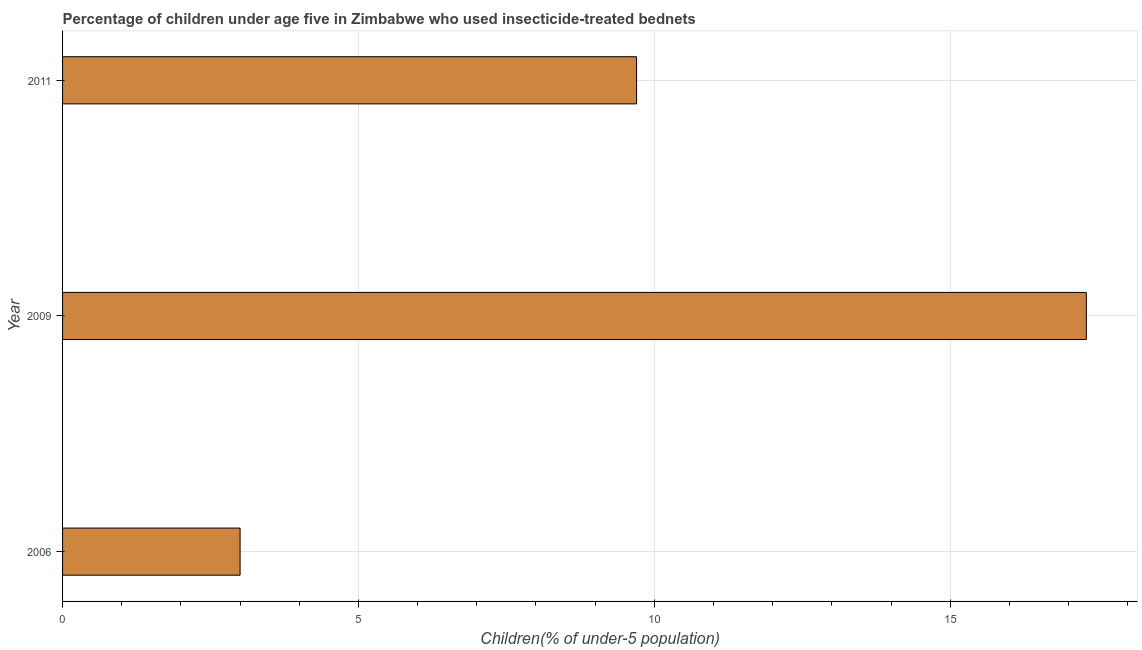Does the graph contain grids?
Ensure brevity in your answer.  Yes. What is the title of the graph?
Keep it short and to the point. Percentage of children under age five in Zimbabwe who used insecticide-treated bednets. What is the label or title of the X-axis?
Provide a short and direct response. Children(% of under-5 population). What is the label or title of the Y-axis?
Keep it short and to the point. Year. Across all years, what is the maximum percentage of children who use of insecticide-treated bed nets?
Provide a short and direct response. 17.3. What is the difference between the percentage of children who use of insecticide-treated bed nets in 2006 and 2011?
Provide a succinct answer. -6.7. What is the median percentage of children who use of insecticide-treated bed nets?
Offer a very short reply. 9.7. Do a majority of the years between 2009 and 2011 (inclusive) have percentage of children who use of insecticide-treated bed nets greater than 16 %?
Ensure brevity in your answer.  No. What is the ratio of the percentage of children who use of insecticide-treated bed nets in 2006 to that in 2009?
Provide a short and direct response. 0.17. Is the difference between the percentage of children who use of insecticide-treated bed nets in 2006 and 2009 greater than the difference between any two years?
Provide a succinct answer. Yes. What is the difference between the highest and the lowest percentage of children who use of insecticide-treated bed nets?
Keep it short and to the point. 14.3. In how many years, is the percentage of children who use of insecticide-treated bed nets greater than the average percentage of children who use of insecticide-treated bed nets taken over all years?
Your answer should be very brief. 1. How many years are there in the graph?
Provide a succinct answer. 3. Are the values on the major ticks of X-axis written in scientific E-notation?
Keep it short and to the point. No. What is the Children(% of under-5 population) of 2006?
Make the answer very short. 3. What is the Children(% of under-5 population) in 2011?
Offer a very short reply. 9.7. What is the difference between the Children(% of under-5 population) in 2006 and 2009?
Provide a short and direct response. -14.3. What is the difference between the Children(% of under-5 population) in 2009 and 2011?
Offer a very short reply. 7.6. What is the ratio of the Children(% of under-5 population) in 2006 to that in 2009?
Offer a very short reply. 0.17. What is the ratio of the Children(% of under-5 population) in 2006 to that in 2011?
Offer a terse response. 0.31. What is the ratio of the Children(% of under-5 population) in 2009 to that in 2011?
Offer a terse response. 1.78. 